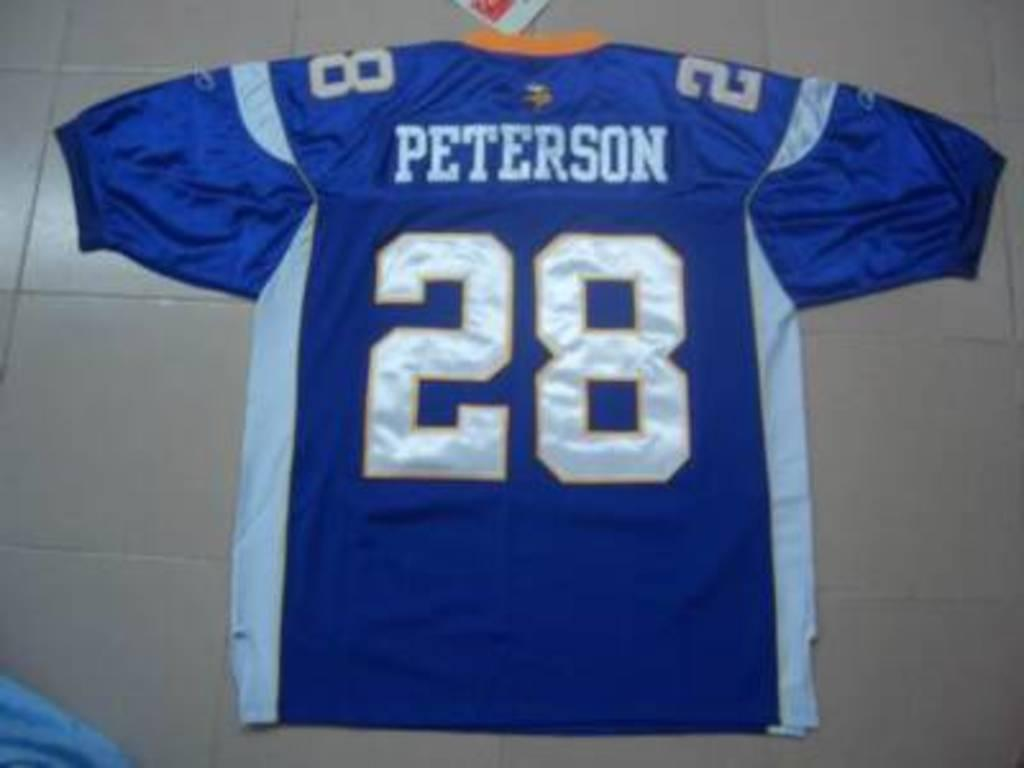<image>
Give a short and clear explanation of the subsequent image. A blue and white jersey that says Peterson 28 in white letters. 